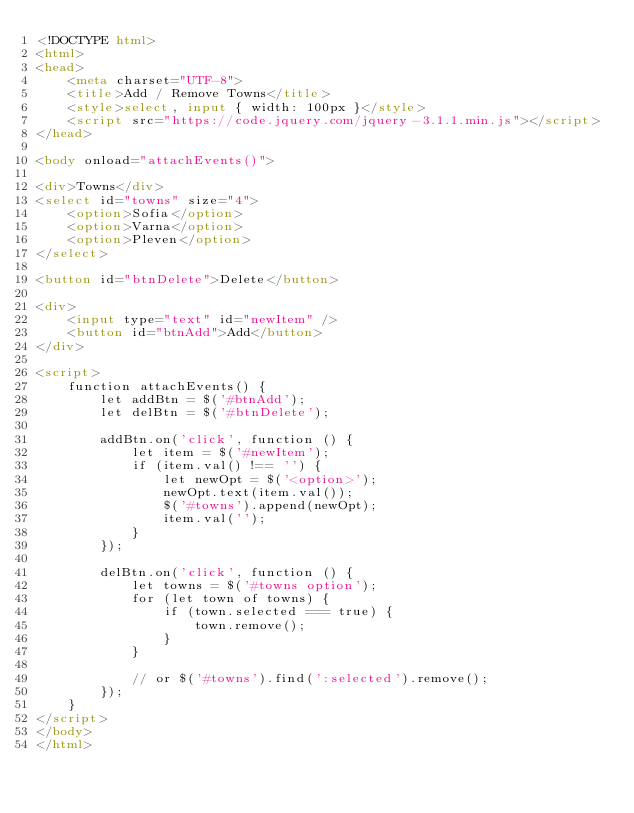Convert code to text. <code><loc_0><loc_0><loc_500><loc_500><_HTML_><!DOCTYPE html>
<html>
<head>
    <meta charset="UTF-8">
    <title>Add / Remove Towns</title>
    <style>select, input { width: 100px }</style>
    <script src="https://code.jquery.com/jquery-3.1.1.min.js"></script>
</head>

<body onload="attachEvents()">

<div>Towns</div>
<select id="towns" size="4">
    <option>Sofia</option>
    <option>Varna</option>
    <option>Pleven</option>
</select>

<button id="btnDelete">Delete</button>

<div>
    <input type="text" id="newItem" />
    <button id="btnAdd">Add</button>
</div>

<script>
    function attachEvents() {
        let addBtn = $('#btnAdd');
        let delBtn = $('#btnDelete');

        addBtn.on('click', function () {
            let item = $('#newItem');
            if (item.val() !== '') {
                let newOpt = $('<option>');
                newOpt.text(item.val());
                $('#towns').append(newOpt);
                item.val('');
            }
        });

        delBtn.on('click', function () {
            let towns = $('#towns option');
            for (let town of towns) {
                if (town.selected === true) {
                    town.remove();
                }
            }

            // or $('#towns').find(':selected').remove();
        });
    }
</script>
</body>
</html></code> 